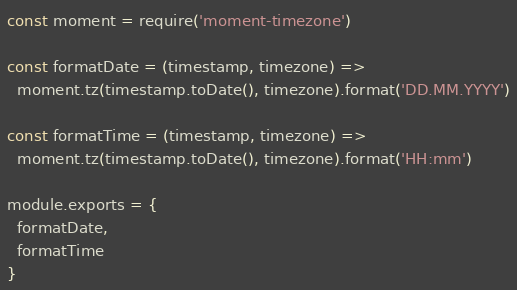<code> <loc_0><loc_0><loc_500><loc_500><_JavaScript_>const moment = require('moment-timezone')

const formatDate = (timestamp, timezone) =>
  moment.tz(timestamp.toDate(), timezone).format('DD.MM.YYYY')

const formatTime = (timestamp, timezone) =>
  moment.tz(timestamp.toDate(), timezone).format('HH:mm')

module.exports = {
  formatDate,
  formatTime
}
</code> 